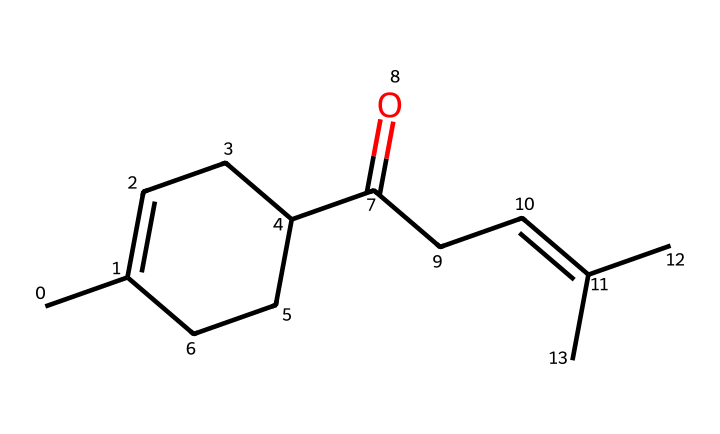What is the molecular formula of jasmone? To deduce the molecular formula from the SMILES representation, we need to count the number of each type of atom present. The provided SMILES indicates a ketone structure. By interpreting the SMILES, we find that there are 15 carbon atoms (C), 24 hydrogen atoms (H), and 1 oxygen atom (O). Therefore, the molecular formula is C15H24O.
Answer: C15H24O How many carbon atoms are in the jasmone molecule? By analyzing the SMILES representation, we can count the carbon atoms directly. The structure shows a total of 15 carbon atoms, which are represented as 'C' in the SMILES notation.
Answer: 15 What type of functional group is present in jasmone? In the SMILES structure, there is a C(=O) part which indicates the presence of a carbonyl group, characteristic of ketones. This functional group differentiates jasmone from other types of compounds.
Answer: ketone What is the primary characteristic that gives jasmone its floral scent? The ketone structure, specifically the presence of the chain of carbon and the carbonyl group (C=O), contributes to its floral aroma, as is common with many aromatic compounds. Floral scents often arise from similar carbon chain systems and functional groups.
Answer: carbon chain Is jasmone a saturated or unsaturated compound? The presence of double bonds in the carbon chain can be observed from the SMILES string (indicated by C=C). This indicates that jasmone has carbon-carbon double bonds, making it unsaturated.
Answer: unsaturated What is the role of the ketone group in jasmone's chemical behavior? The ketone group (C=O) can participate in hydrogen bonding, influencing the volatility and reactivity of jasmone. This characteristic plays a crucial role in its behavior as a fragrance compound, affecting how it evaporates and interacts with olfactory receptors.
Answer: hydrogen bonding 